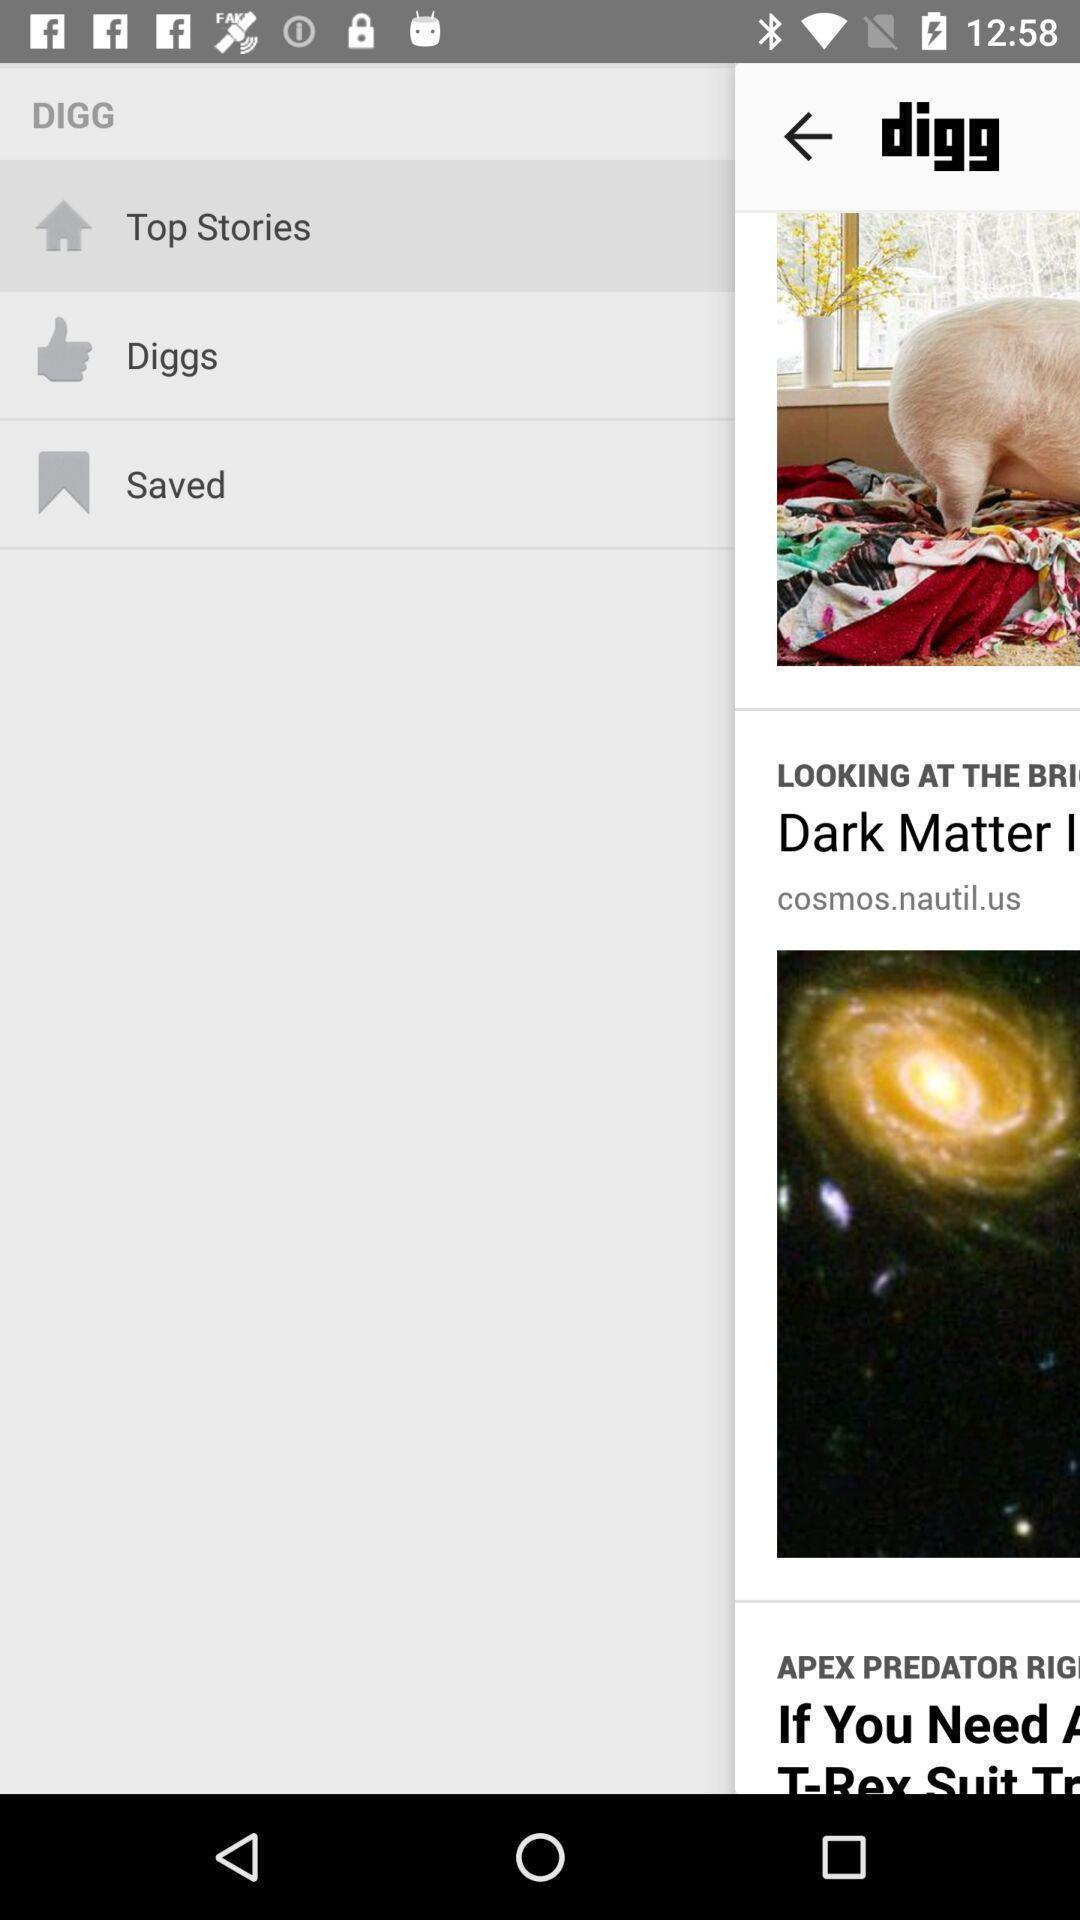Explain what's happening in this screen capture. Top stories is highlighted among the features. 